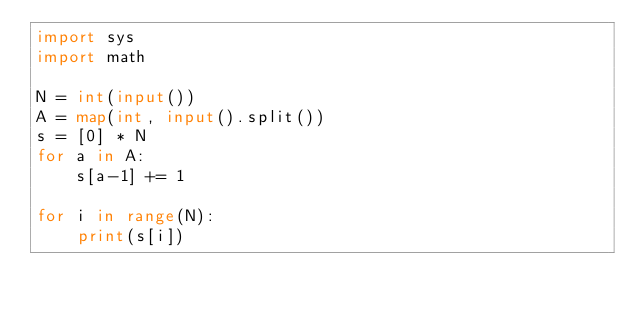<code> <loc_0><loc_0><loc_500><loc_500><_Python_>import sys
import math

N = int(input())
A = map(int, input().split())
s = [0] * N
for a in A:
    s[a-1] += 1

for i in range(N):
    print(s[i])
</code> 